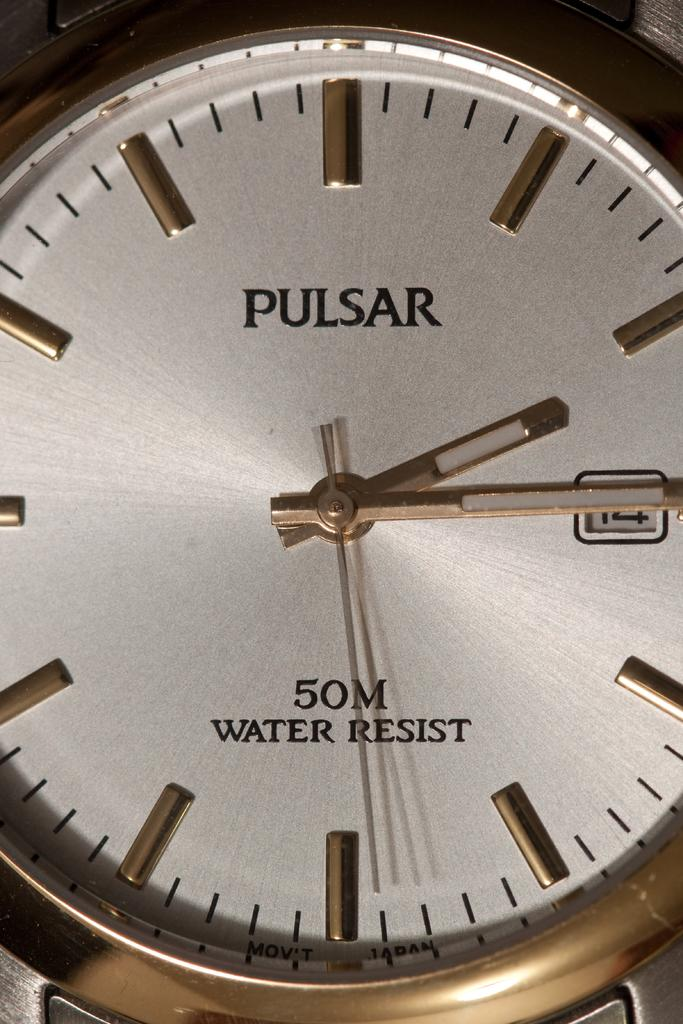<image>
Render a clear and concise summary of the photo. A gold and white Pulsar water resistant watch. 